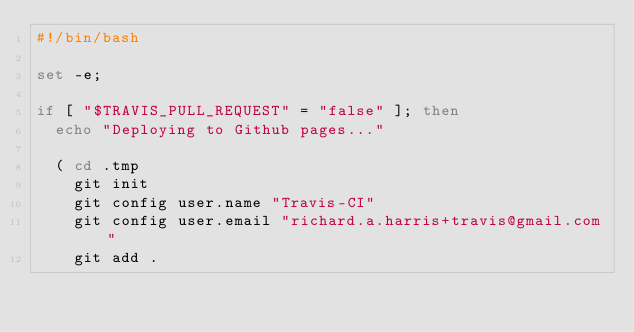Convert code to text. <code><loc_0><loc_0><loc_500><loc_500><_Bash_>#!/bin/bash

set -e;

if [ "$TRAVIS_PULL_REQUEST" = "false" ]; then
	echo "Deploying to Github pages..."

	( cd .tmp
		git init
		git config user.name "Travis-CI"
		git config user.email "richard.a.harris+travis@gmail.com"
		git add .</code> 